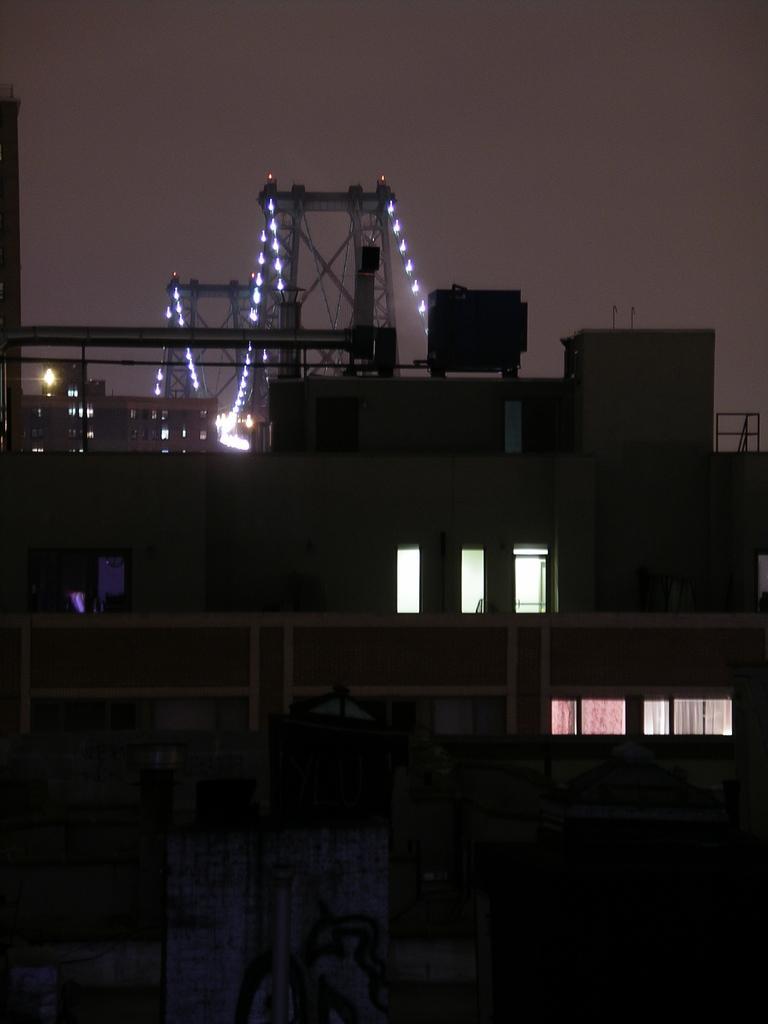Can you describe this image briefly? In this image there are buildings and we can see a bridge. There are lights. In the background there is sky. 